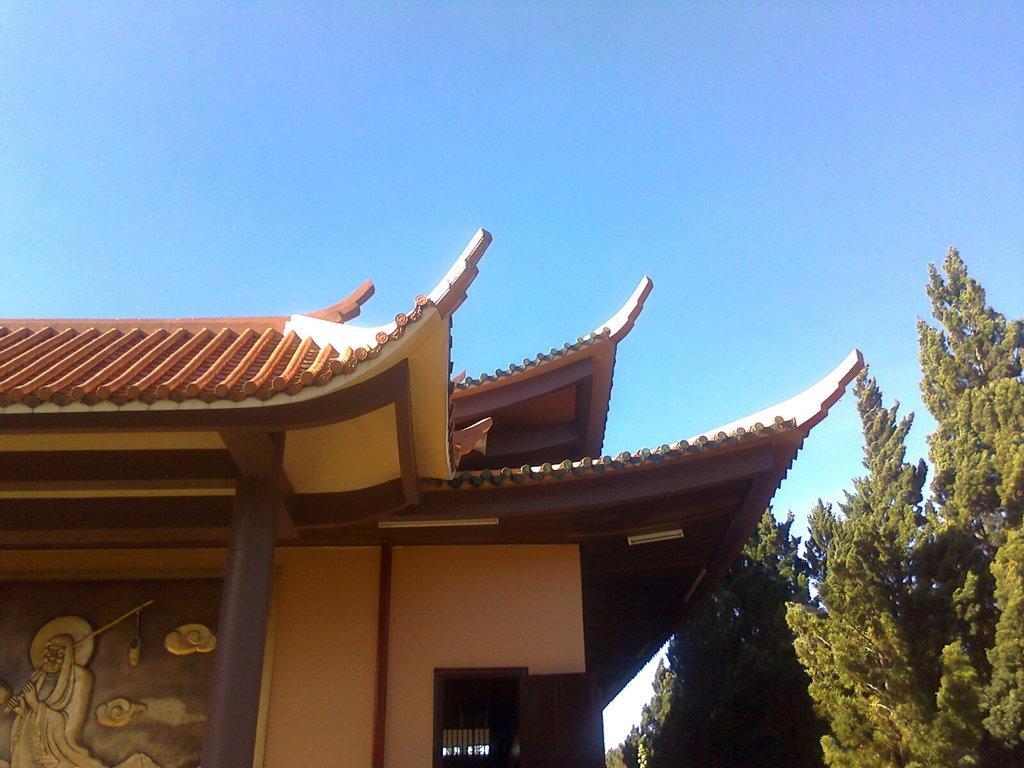Can you describe this image briefly? On the left side it looks like a house, on the right side there are trees. At the top it is the blue color sky. 